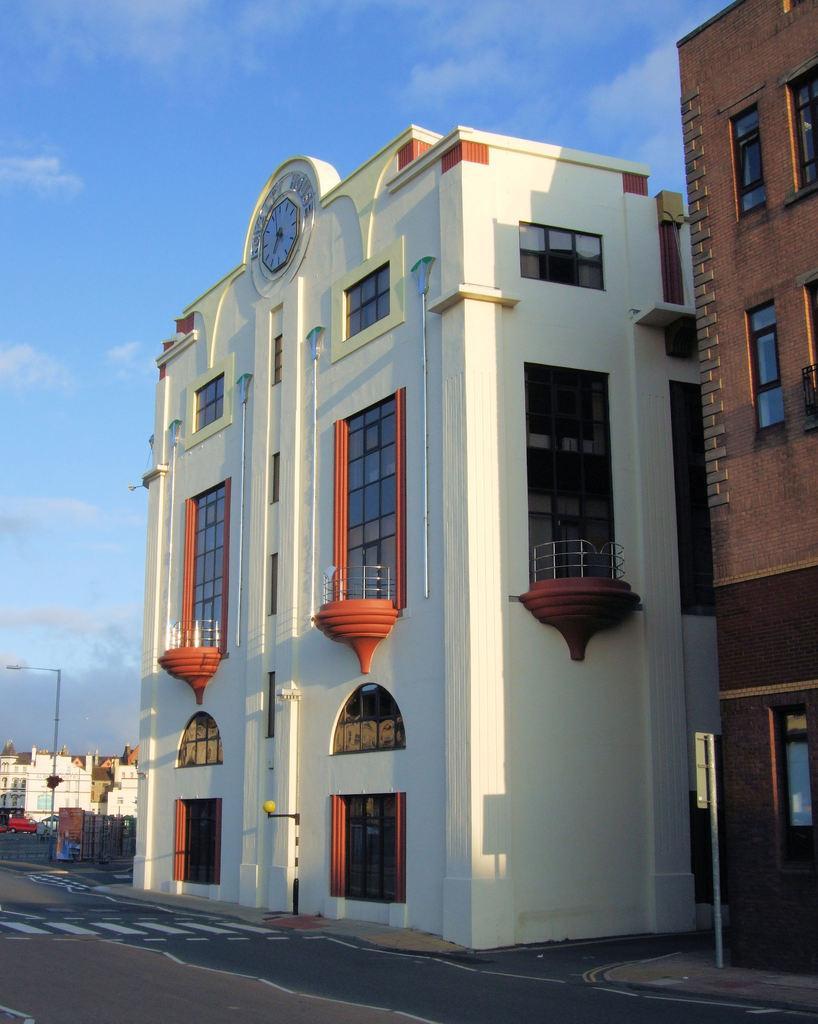Could you give a brief overview of what you see in this image? In this image there are buildings, pole, road, cloudy sky, clock and objects.   